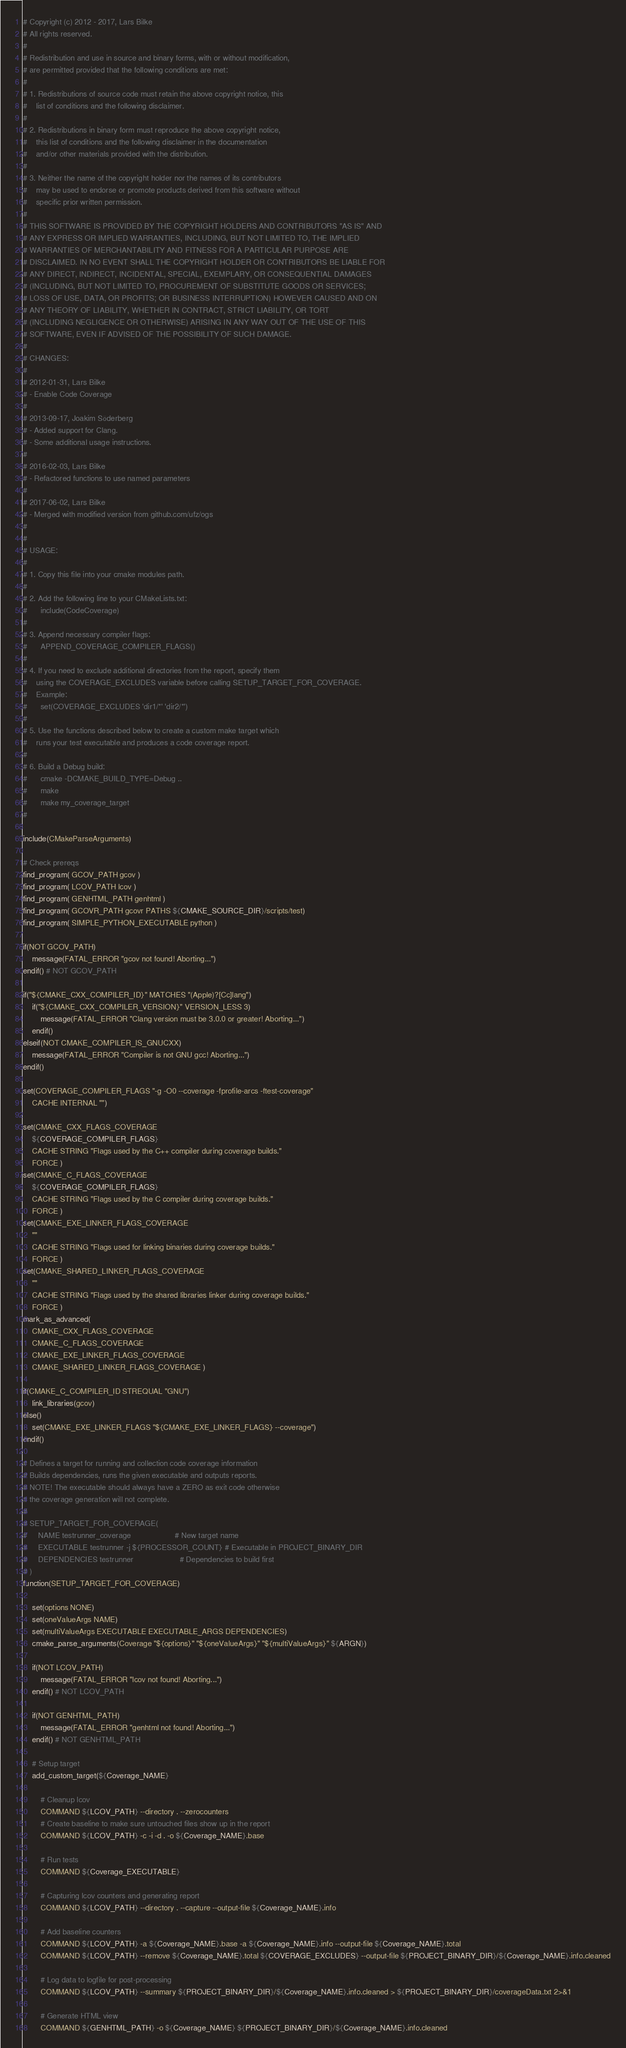Convert code to text. <code><loc_0><loc_0><loc_500><loc_500><_CMake_># Copyright (c) 2012 - 2017, Lars Bilke
# All rights reserved.
#
# Redistribution and use in source and binary forms, with or without modification,
# are permitted provided that the following conditions are met:
#
# 1. Redistributions of source code must retain the above copyright notice, this
#    list of conditions and the following disclaimer.
#
# 2. Redistributions in binary form must reproduce the above copyright notice,
#    this list of conditions and the following disclaimer in the documentation
#    and/or other materials provided with the distribution.
#
# 3. Neither the name of the copyright holder nor the names of its contributors
#    may be used to endorse or promote products derived from this software without
#    specific prior written permission.
#
# THIS SOFTWARE IS PROVIDED BY THE COPYRIGHT HOLDERS AND CONTRIBUTORS "AS IS" AND
# ANY EXPRESS OR IMPLIED WARRANTIES, INCLUDING, BUT NOT LIMITED TO, THE IMPLIED
# WARRANTIES OF MERCHANTABILITY AND FITNESS FOR A PARTICULAR PURPOSE ARE
# DISCLAIMED. IN NO EVENT SHALL THE COPYRIGHT HOLDER OR CONTRIBUTORS BE LIABLE FOR
# ANY DIRECT, INDIRECT, INCIDENTAL, SPECIAL, EXEMPLARY, OR CONSEQUENTIAL DAMAGES
# (INCLUDING, BUT NOT LIMITED TO, PROCUREMENT OF SUBSTITUTE GOODS OR SERVICES;
# LOSS OF USE, DATA, OR PROFITS; OR BUSINESS INTERRUPTION) HOWEVER CAUSED AND ON
# ANY THEORY OF LIABILITY, WHETHER IN CONTRACT, STRICT LIABILITY, OR TORT
# (INCLUDING NEGLIGENCE OR OTHERWISE) ARISING IN ANY WAY OUT OF THE USE OF THIS
# SOFTWARE, EVEN IF ADVISED OF THE POSSIBILITY OF SUCH DAMAGE.
#
# CHANGES:
#
# 2012-01-31, Lars Bilke
# - Enable Code Coverage
#
# 2013-09-17, Joakim Söderberg
# - Added support for Clang.
# - Some additional usage instructions.
#
# 2016-02-03, Lars Bilke
# - Refactored functions to use named parameters
#
# 2017-06-02, Lars Bilke
# - Merged with modified version from github.com/ufz/ogs
#
#
# USAGE:
#
# 1. Copy this file into your cmake modules path.
#
# 2. Add the following line to your CMakeLists.txt:
#      include(CodeCoverage)
#
# 3. Append necessary compiler flags:
#      APPEND_COVERAGE_COMPILER_FLAGS()
#
# 4. If you need to exclude additional directories from the report, specify them
#    using the COVERAGE_EXCLUDES variable before calling SETUP_TARGET_FOR_COVERAGE.
#    Example:
#      set(COVERAGE_EXCLUDES 'dir1/*' 'dir2/*')
#
# 5. Use the functions described below to create a custom make target which
#    runs your test executable and produces a code coverage report.
#
# 6. Build a Debug build:
#      cmake -DCMAKE_BUILD_TYPE=Debug ..
#      make
#      make my_coverage_target
#

include(CMakeParseArguments)

# Check prereqs
find_program( GCOV_PATH gcov )
find_program( LCOV_PATH lcov )
find_program( GENHTML_PATH genhtml )
find_program( GCOVR_PATH gcovr PATHS ${CMAKE_SOURCE_DIR}/scripts/test)
find_program( SIMPLE_PYTHON_EXECUTABLE python )

if(NOT GCOV_PATH)
    message(FATAL_ERROR "gcov not found! Aborting...")
endif() # NOT GCOV_PATH

if("${CMAKE_CXX_COMPILER_ID}" MATCHES "(Apple)?[Cc]lang")
    if("${CMAKE_CXX_COMPILER_VERSION}" VERSION_LESS 3)
        message(FATAL_ERROR "Clang version must be 3.0.0 or greater! Aborting...")
    endif()
elseif(NOT CMAKE_COMPILER_IS_GNUCXX)
    message(FATAL_ERROR "Compiler is not GNU gcc! Aborting...")
endif()

set(COVERAGE_COMPILER_FLAGS "-g -O0 --coverage -fprofile-arcs -ftest-coverage"
    CACHE INTERNAL "")

set(CMAKE_CXX_FLAGS_COVERAGE
    ${COVERAGE_COMPILER_FLAGS}
    CACHE STRING "Flags used by the C++ compiler during coverage builds."
    FORCE )
set(CMAKE_C_FLAGS_COVERAGE
    ${COVERAGE_COMPILER_FLAGS}
    CACHE STRING "Flags used by the C compiler during coverage builds."
    FORCE )
set(CMAKE_EXE_LINKER_FLAGS_COVERAGE
    ""
    CACHE STRING "Flags used for linking binaries during coverage builds."
    FORCE )
set(CMAKE_SHARED_LINKER_FLAGS_COVERAGE
    ""
    CACHE STRING "Flags used by the shared libraries linker during coverage builds."
    FORCE )
mark_as_advanced(
    CMAKE_CXX_FLAGS_COVERAGE
    CMAKE_C_FLAGS_COVERAGE
    CMAKE_EXE_LINKER_FLAGS_COVERAGE
    CMAKE_SHARED_LINKER_FLAGS_COVERAGE )

if(CMAKE_C_COMPILER_ID STREQUAL "GNU")
    link_libraries(gcov)
else()
    set(CMAKE_EXE_LINKER_FLAGS "${CMAKE_EXE_LINKER_FLAGS} --coverage")
endif()

# Defines a target for running and collection code coverage information
# Builds dependencies, runs the given executable and outputs reports.
# NOTE! The executable should always have a ZERO as exit code otherwise
# the coverage generation will not complete.
#
# SETUP_TARGET_FOR_COVERAGE(
#     NAME testrunner_coverage                    # New target name
#     EXECUTABLE testrunner -j ${PROCESSOR_COUNT} # Executable in PROJECT_BINARY_DIR
#     DEPENDENCIES testrunner                     # Dependencies to build first
# )
function(SETUP_TARGET_FOR_COVERAGE)

    set(options NONE)
    set(oneValueArgs NAME)
    set(multiValueArgs EXECUTABLE EXECUTABLE_ARGS DEPENDENCIES)
    cmake_parse_arguments(Coverage "${options}" "${oneValueArgs}" "${multiValueArgs}" ${ARGN})

    if(NOT LCOV_PATH)
        message(FATAL_ERROR "lcov not found! Aborting...")
    endif() # NOT LCOV_PATH

    if(NOT GENHTML_PATH)
        message(FATAL_ERROR "genhtml not found! Aborting...")
    endif() # NOT GENHTML_PATH

    # Setup target
    add_custom_target(${Coverage_NAME}

        # Cleanup lcov
        COMMAND ${LCOV_PATH} --directory . --zerocounters
        # Create baseline to make sure untouched files show up in the report
        COMMAND ${LCOV_PATH} -c -i -d . -o ${Coverage_NAME}.base

        # Run tests
        COMMAND ${Coverage_EXECUTABLE}

        # Capturing lcov counters and generating report
        COMMAND ${LCOV_PATH} --directory . --capture --output-file ${Coverage_NAME}.info

        # Add baseline counters
        COMMAND ${LCOV_PATH} -a ${Coverage_NAME}.base -a ${Coverage_NAME}.info --output-file ${Coverage_NAME}.total
        COMMAND ${LCOV_PATH} --remove ${Coverage_NAME}.total ${COVERAGE_EXCLUDES} --output-file ${PROJECT_BINARY_DIR}/${Coverage_NAME}.info.cleaned

        # Log data to logfile for post-processing
        COMMAND ${LCOV_PATH} --summary ${PROJECT_BINARY_DIR}/${Coverage_NAME}.info.cleaned > ${PROJECT_BINARY_DIR}/coverageData.txt 2>&1

        # Generate HTML view
        COMMAND ${GENHTML_PATH} -o ${Coverage_NAME} ${PROJECT_BINARY_DIR}/${Coverage_NAME}.info.cleaned</code> 